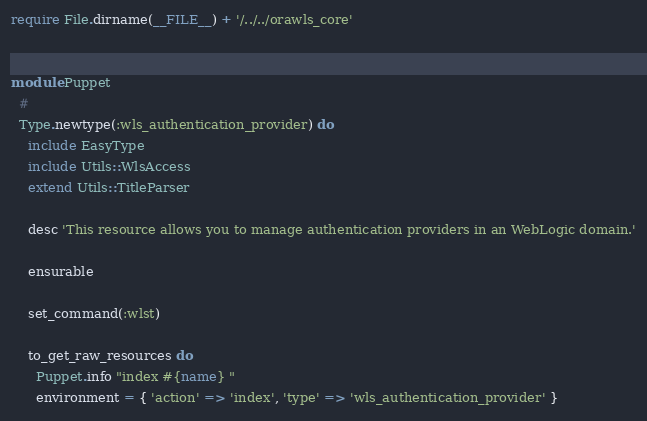Convert code to text. <code><loc_0><loc_0><loc_500><loc_500><_Ruby_>require File.dirname(__FILE__) + '/../../orawls_core'


module Puppet
  #
  Type.newtype(:wls_authentication_provider) do
    include EasyType
    include Utils::WlsAccess
    extend Utils::TitleParser

    desc 'This resource allows you to manage authentication providers in an WebLogic domain.'

    ensurable

    set_command(:wlst)

    to_get_raw_resources do
      Puppet.info "index #{name} "
      environment = { 'action' => 'index', 'type' => 'wls_authentication_provider' }</code> 